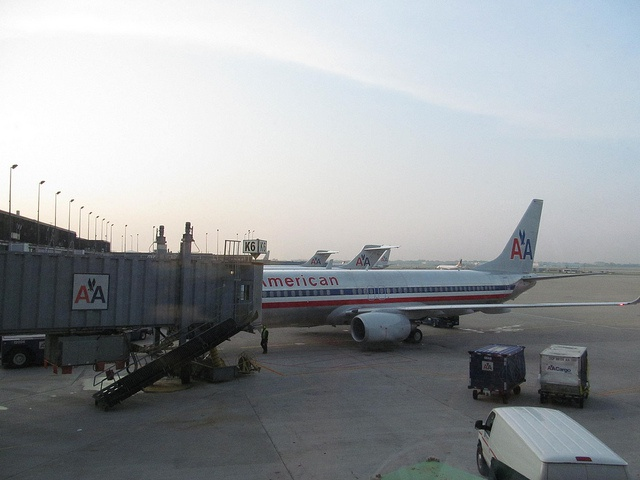Describe the objects in this image and their specific colors. I can see airplane in white, gray, and black tones, truck in white, darkgray, gray, and black tones, truck in white, gray, and black tones, truck in white, black, and gray tones, and airplane in white, gray, darkgray, and lightgray tones in this image. 